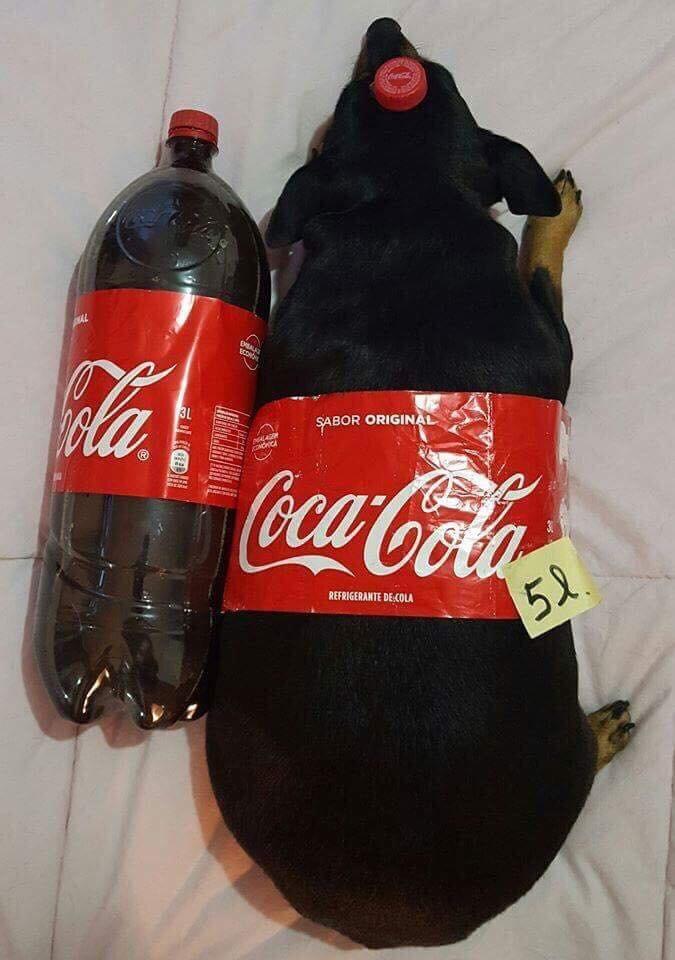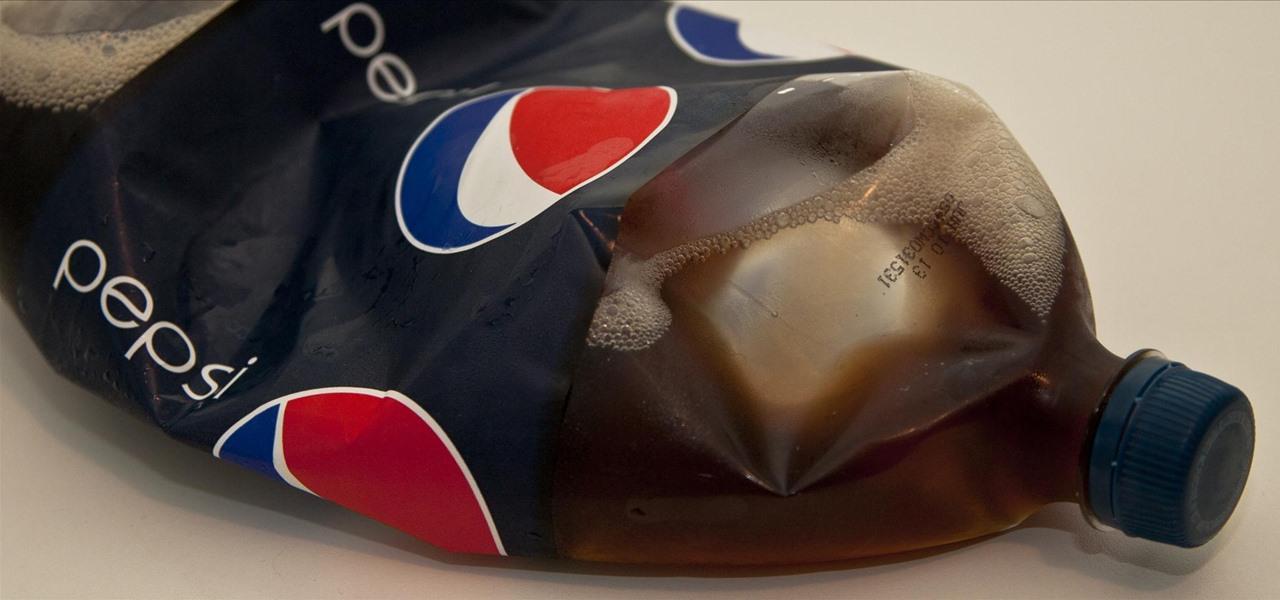The first image is the image on the left, the second image is the image on the right. Assess this claim about the two images: "One of the images contains a Pepsi product.". Correct or not? Answer yes or no. Yes. 